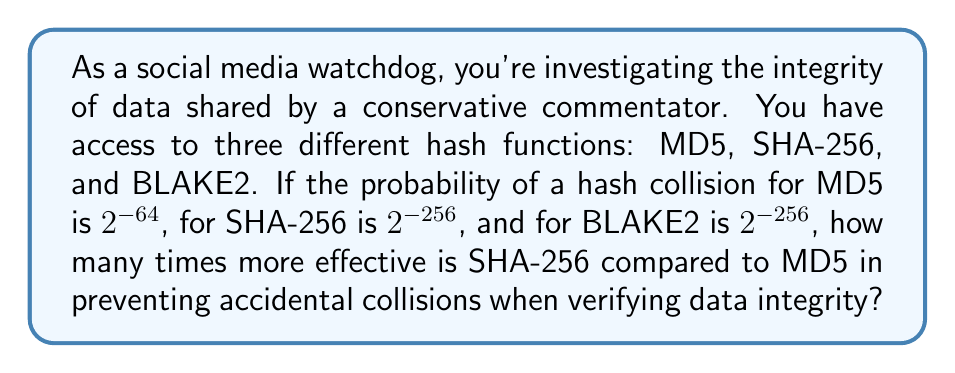Can you solve this math problem? To determine how many times more effective SHA-256 is compared to MD5, we need to compare their collision probabilities:

1) MD5 collision probability: $P_{MD5} = 2^{-64}$
2) SHA-256 collision probability: $P_{SHA-256} = 2^{-256}$

3) To find how many times more effective SHA-256 is, we divide the MD5 probability by the SHA-256 probability:

   $\frac{P_{MD5}}{P_{SHA-256}} = \frac{2^{-64}}{2^{-256}}$

4) Using the laws of exponents, we can simplify this:

   $\frac{2^{-64}}{2^{-256}} = 2^{-64 - (-256)} = 2^{-64 + 256} = 2^{192}$

5) Therefore, SHA-256 is $2^{192}$ times more effective than MD5 in preventing accidental collisions.

This immense difference highlights why stronger hash functions like SHA-256 are crucial for maintaining data integrity in sensitive applications, such as fact-checking potentially misleading claims from public figures.
Answer: $2^{192}$ 